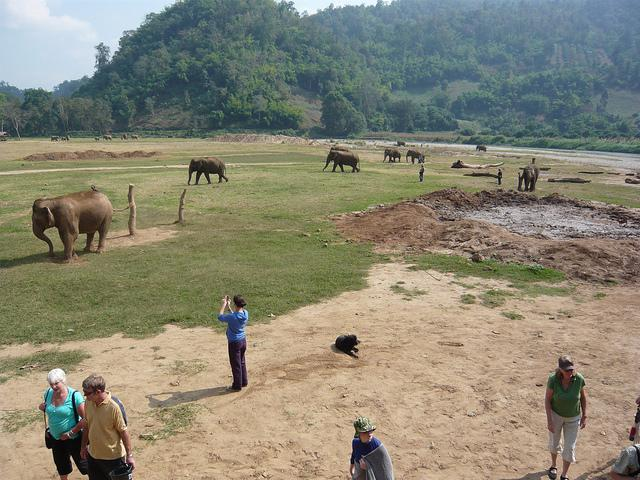The person holding the camera is wearing what color shirt? Please explain your reasoning. blue. The woman aiming a camera is in a blue shirt. 